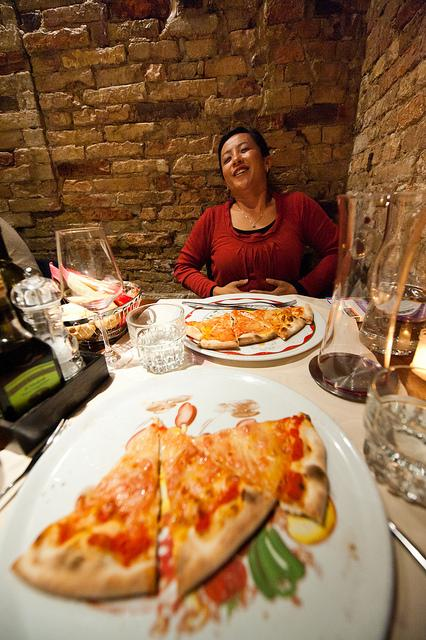What type of food is served here?

Choices:
A) italian
B) thai
C) korean
D) chinese italian 